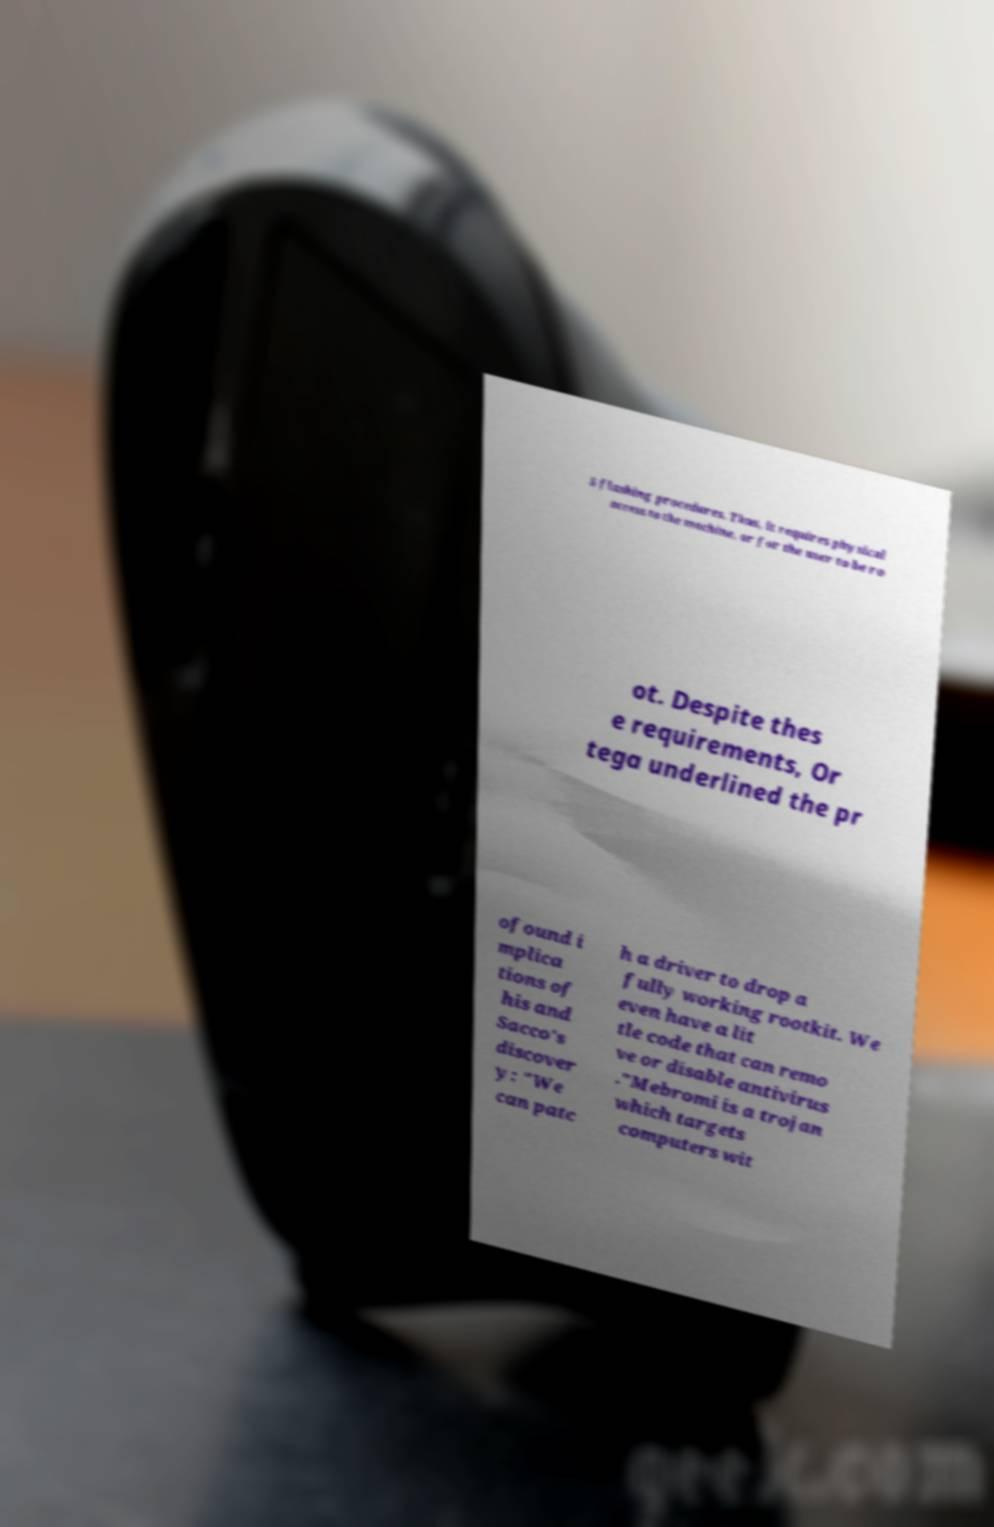Please identify and transcribe the text found in this image. S flashing procedures. Thus, it requires physical access to the machine, or for the user to be ro ot. Despite thes e requirements, Or tega underlined the pr ofound i mplica tions of his and Sacco's discover y: "We can patc h a driver to drop a fully working rootkit. We even have a lit tle code that can remo ve or disable antivirus ."Mebromi is a trojan which targets computers wit 